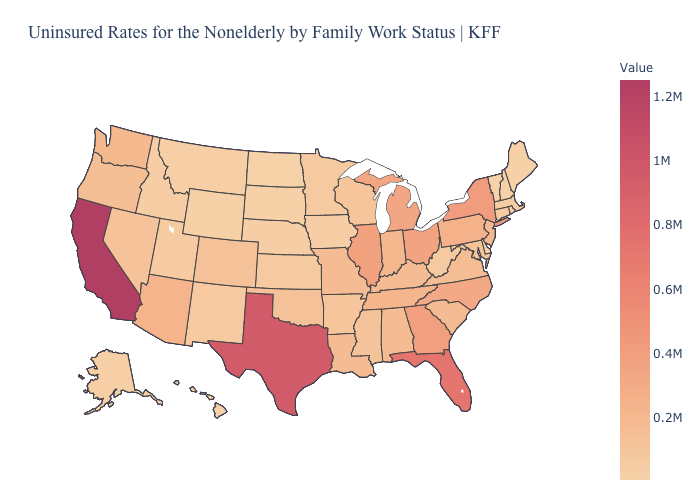Is the legend a continuous bar?
Concise answer only. Yes. Does Tennessee have a lower value than Texas?
Short answer required. Yes. Which states hav the highest value in the MidWest?
Keep it brief. Illinois. 